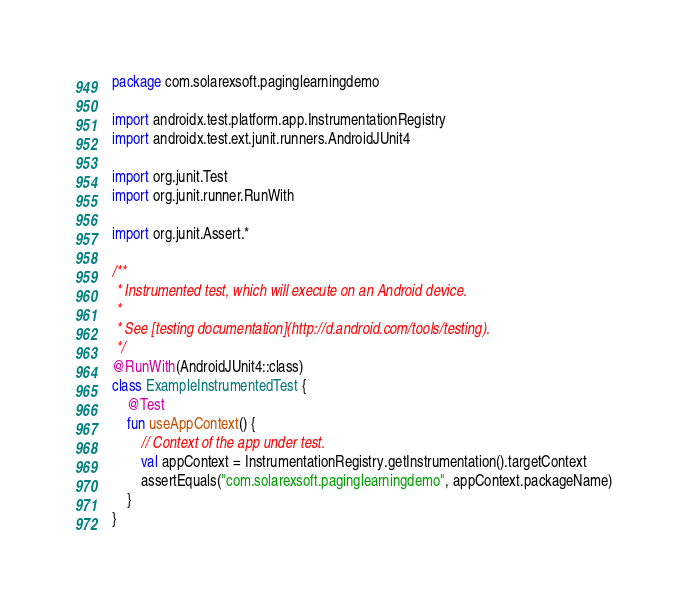<code> <loc_0><loc_0><loc_500><loc_500><_Kotlin_>package com.solarexsoft.paginglearningdemo

import androidx.test.platform.app.InstrumentationRegistry
import androidx.test.ext.junit.runners.AndroidJUnit4

import org.junit.Test
import org.junit.runner.RunWith

import org.junit.Assert.*

/**
 * Instrumented test, which will execute on an Android device.
 *
 * See [testing documentation](http://d.android.com/tools/testing).
 */
@RunWith(AndroidJUnit4::class)
class ExampleInstrumentedTest {
    @Test
    fun useAppContext() {
        // Context of the app under test.
        val appContext = InstrumentationRegistry.getInstrumentation().targetContext
        assertEquals("com.solarexsoft.paginglearningdemo", appContext.packageName)
    }
}</code> 